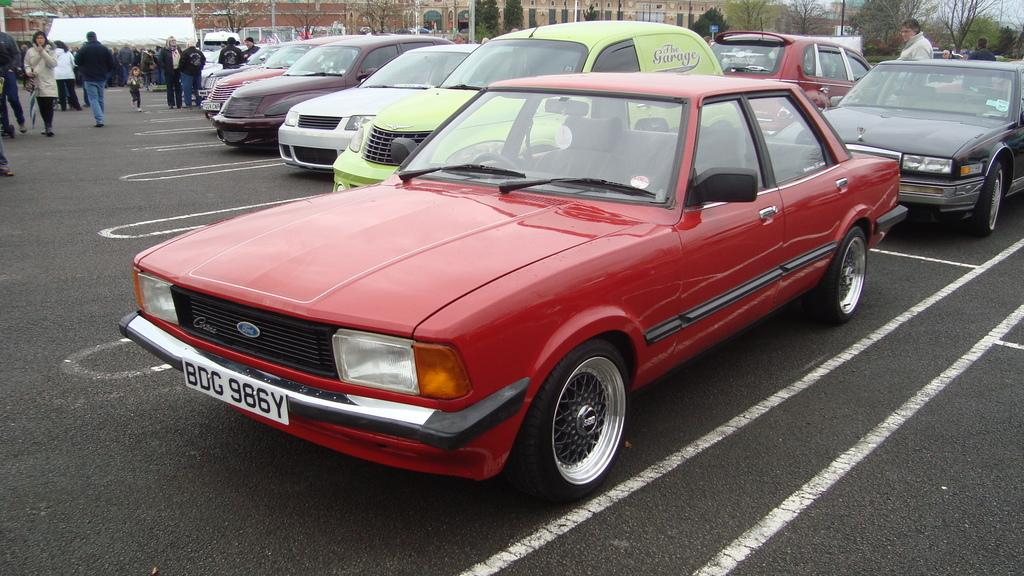What is happening on the road in the image? There are vehicles and a group of people on the road in the image. What can be seen in the background of the image? There are trees, buildings, and the sky visible in the background of the image. Can you see a squirrel looking at the light in the image? There is no squirrel or light present in the image. What type of light is being used by the group of people in the image? There is no specific light mentioned or visible in the image; it only shows vehicles, people, trees, buildings, and the sky. 